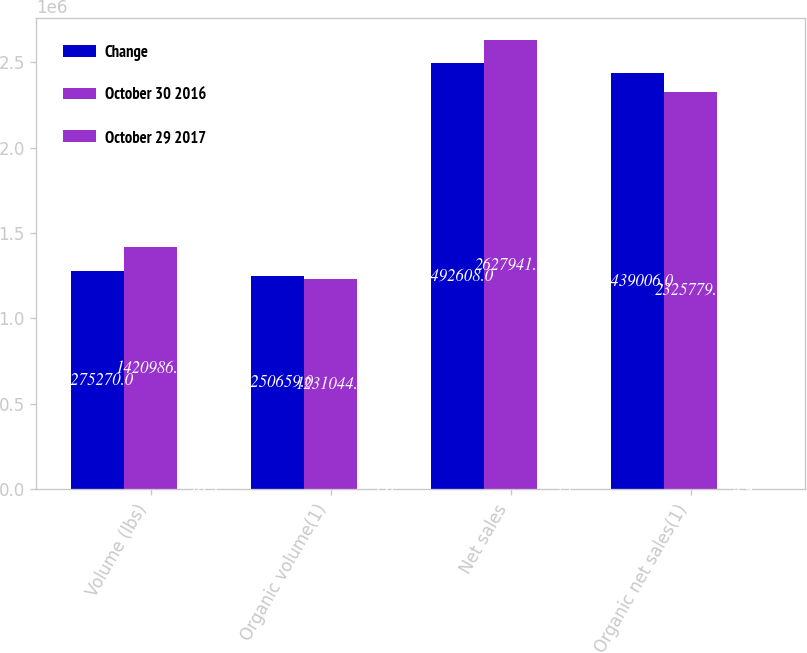Convert chart. <chart><loc_0><loc_0><loc_500><loc_500><stacked_bar_chart><ecel><fcel>Volume (lbs)<fcel>Organic volume(1)<fcel>Net sales<fcel>Organic net sales(1)<nl><fcel>Change<fcel>1.27527e+06<fcel>1.25066e+06<fcel>2.49261e+06<fcel>2.43901e+06<nl><fcel>October 30 2016<fcel>1.42099e+06<fcel>1.23104e+06<fcel>2.62794e+06<fcel>2.32578e+06<nl><fcel>October 29 2017<fcel>10.3<fcel>1.6<fcel>5.1<fcel>4.9<nl></chart> 